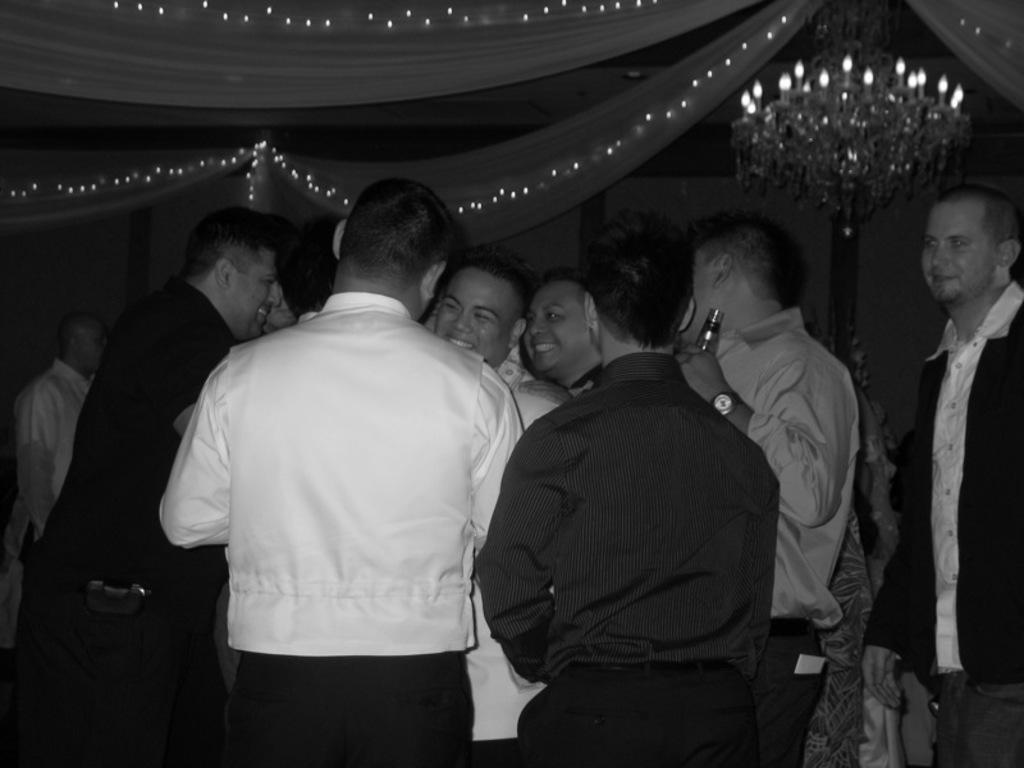Could you give a brief overview of what you see in this image? In this image, we can see a group of people standing and wearing clothes. There are decors at the top of the image. There is a chandelier in the top right of the image. 